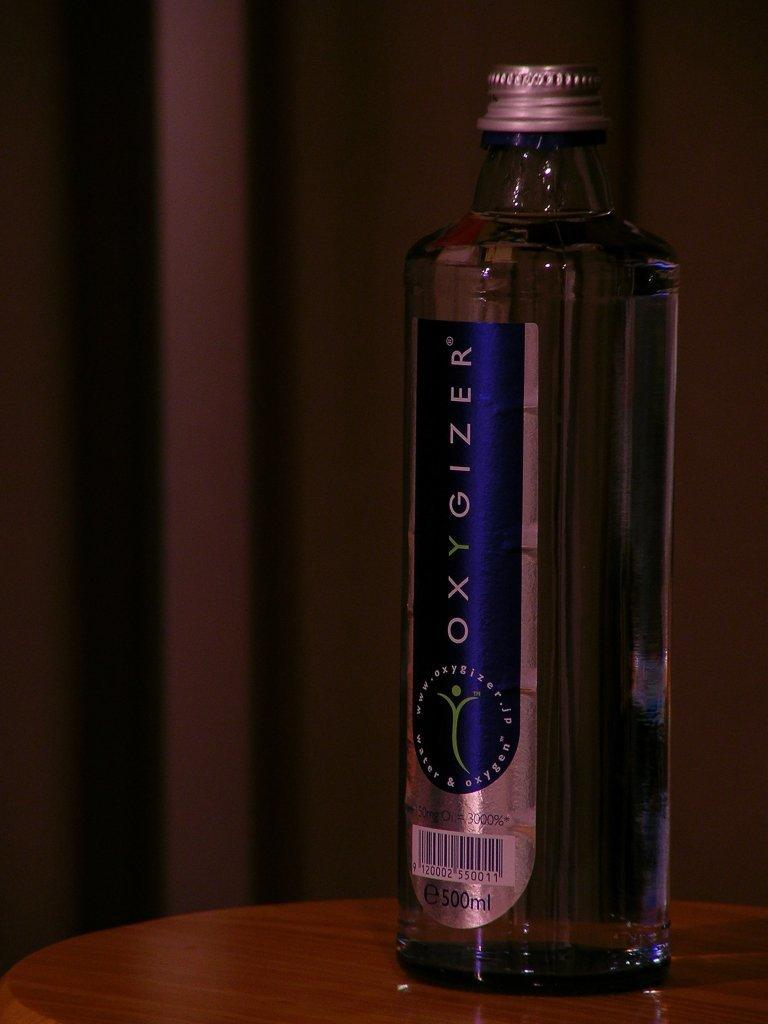<image>
Describe the image concisely. Glass bottle of Oxygizer water and 500 ml. 